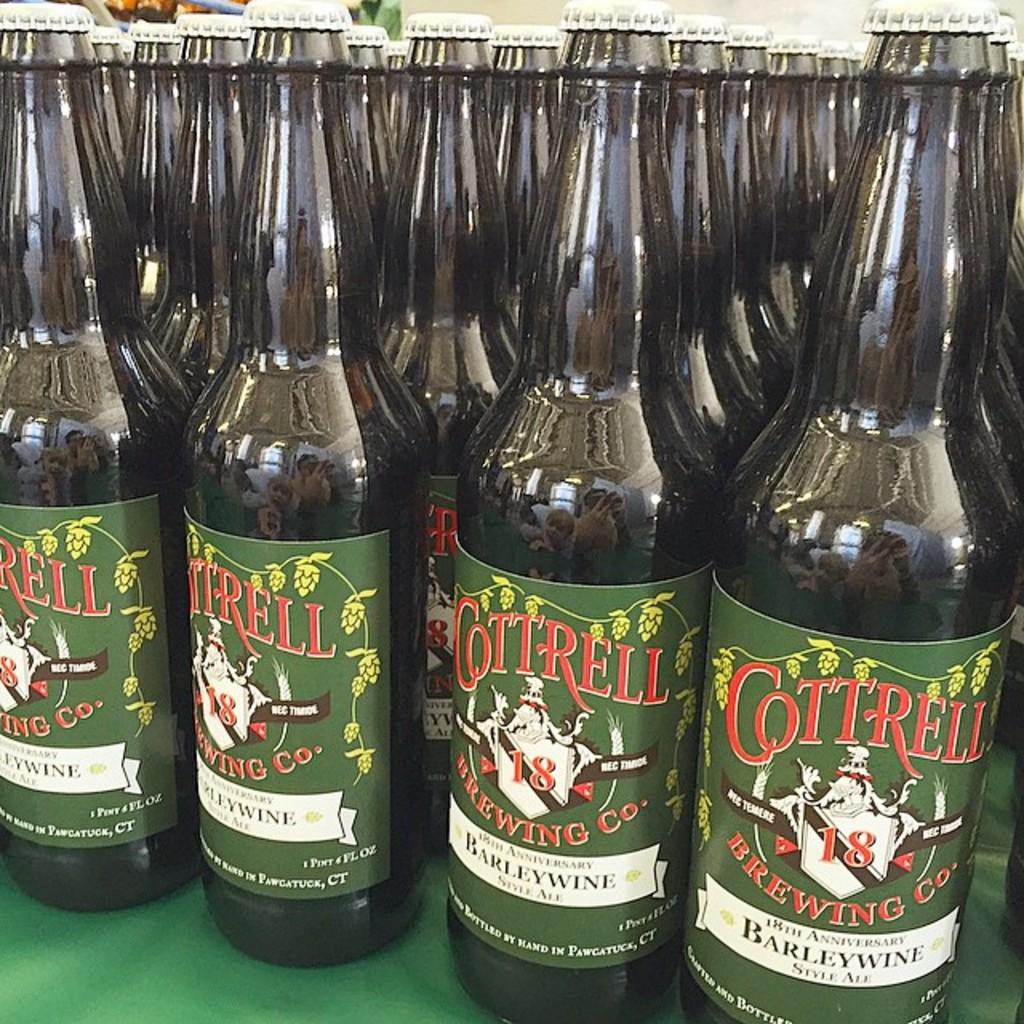What kind of beverage is it?
Make the answer very short. Barleywine. What is the brand?
Offer a very short reply. Cottrell. 